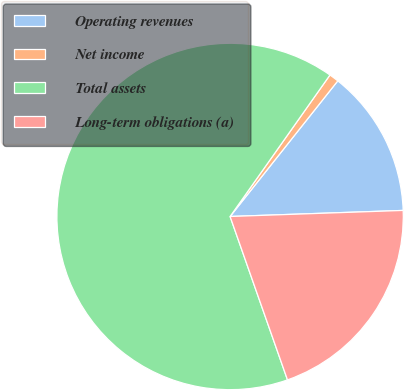Convert chart. <chart><loc_0><loc_0><loc_500><loc_500><pie_chart><fcel>Operating revenues<fcel>Net income<fcel>Total assets<fcel>Long-term obligations (a)<nl><fcel>13.76%<fcel>0.9%<fcel>65.16%<fcel>20.18%<nl></chart> 